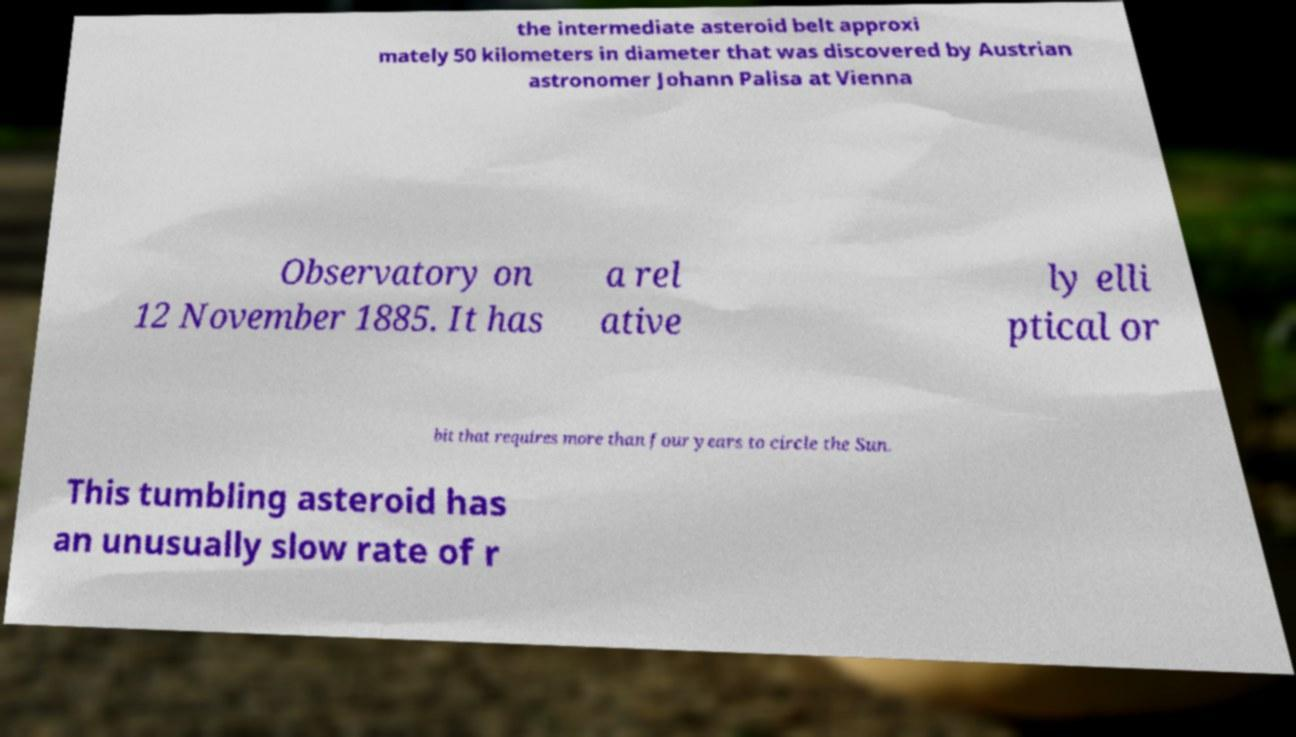I need the written content from this picture converted into text. Can you do that? the intermediate asteroid belt approxi mately 50 kilometers in diameter that was discovered by Austrian astronomer Johann Palisa at Vienna Observatory on 12 November 1885. It has a rel ative ly elli ptical or bit that requires more than four years to circle the Sun. This tumbling asteroid has an unusually slow rate of r 